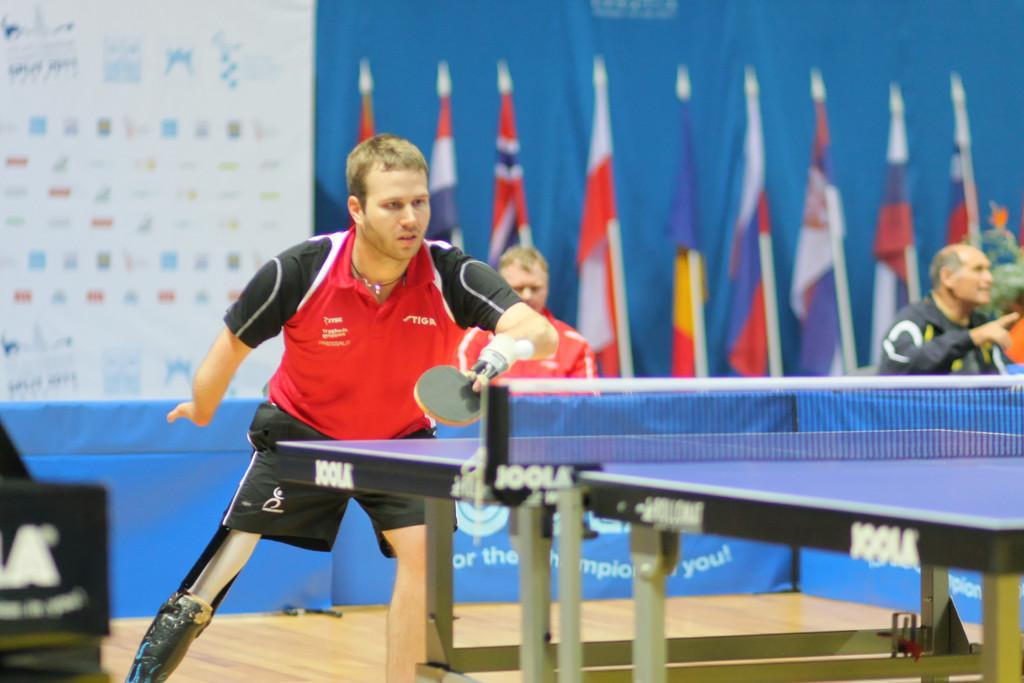<image>
Share a concise interpretation of the image provided. A man with a prosthetic leg is playing ping-pong at a Joola brand table. 